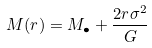<formula> <loc_0><loc_0><loc_500><loc_500>M ( r ) = M _ { \bullet } + \frac { 2 r \sigma ^ { 2 } } { G }</formula> 